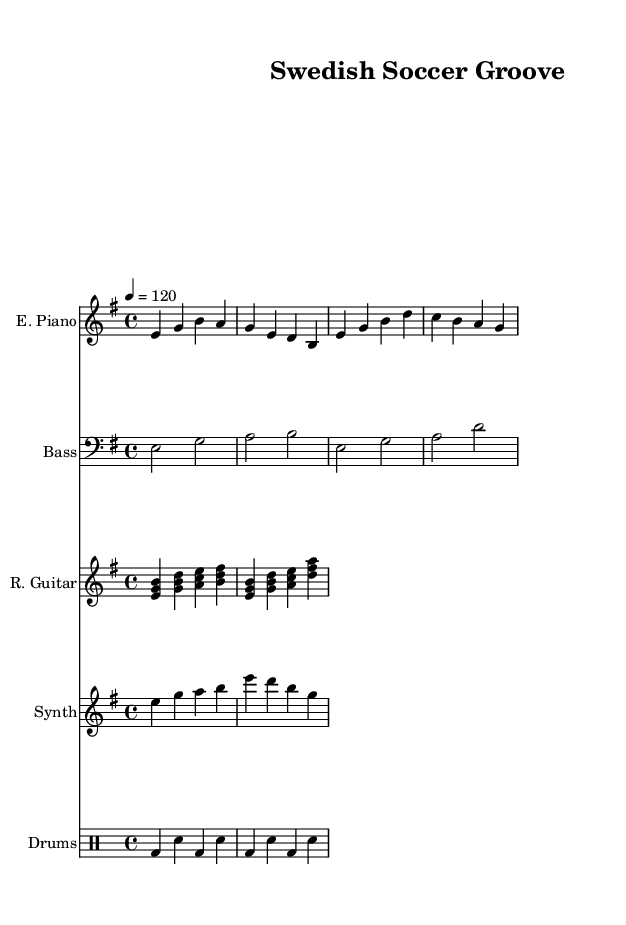What is the key signature of this music? The key signature is indicated at the beginning of the score. Here, there is one sharp (F#) indicated on the staff, which means the key is E minor.
Answer: E minor What is the time signature of this music? The time signature is shown right after the key signature at the beginning of the score. It reads 4/4, which means there are four beats in each measure.
Answer: 4/4 What is the tempo marking? The tempo marking is found near the top of the sheet. It states "4 = 120", indicating the tempo in beats per minute. This means there are 120 beats in one minute, corresponding to a quarter note.
Answer: 120 Which instrument plays the main melody? The main melody is often played by the instrument with the highest pitch in the score. Here, the electric piano has a single melodic line that stands out, making it the primary melody instrument.
Answer: Electric Piano How many different instruments are indicated in the score? To find the number of instruments, count the distinct staffs that show different instrument names. Here, there are five different instruments: Electric Piano, Bass, Rhythm Guitar, Synth, and Drums.
Answer: Five What type of rhythm is most prominent in the drums part? The drums part consists of bass drum (bd) and snare drum (sn) with alternating patterns. The consistent quarter note rhythm clearly indicates the style typical of disco music.
Answer: Disco rhythm 